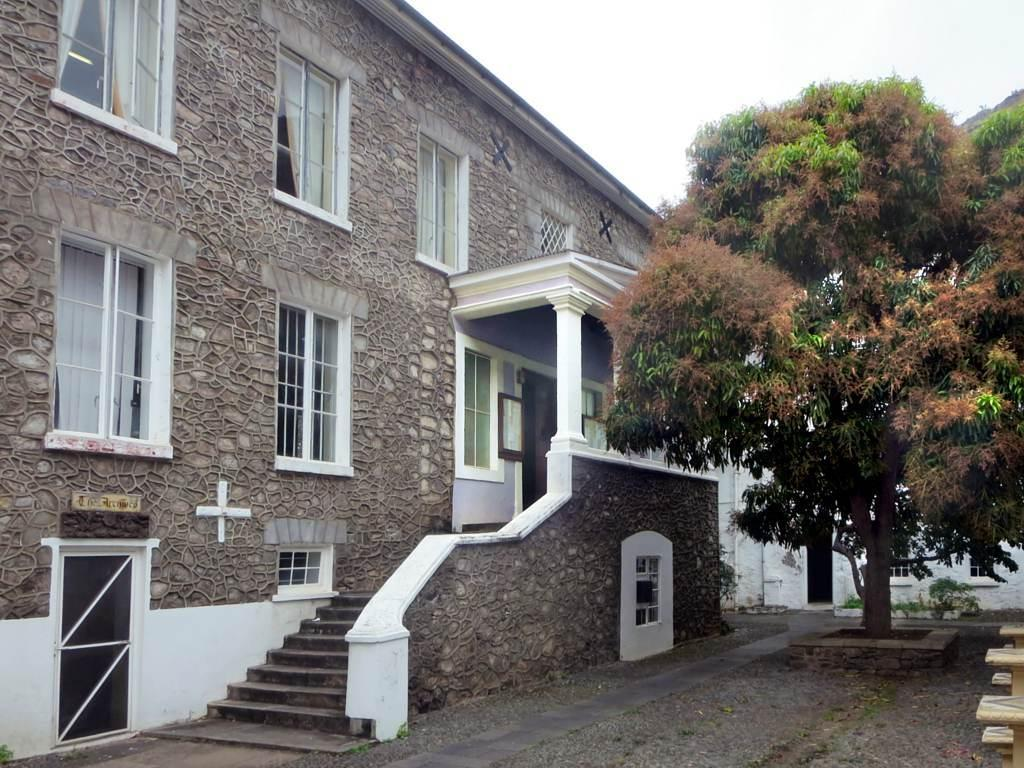What structure is located on the left side of the image? There is a building on the left side of the image. What architectural features can be seen on the building? The building has windows, pillars, doors, and steps with a wall. What type of vegetation is on the right side of the image? There is a tree on the right side of the image. What is visible at the top of the image? The sky is visible at the top of the image. What type of paint is used to color the tree's leaves in the image? There is no paint present in the image; the tree is a natural object with its own coloration. 